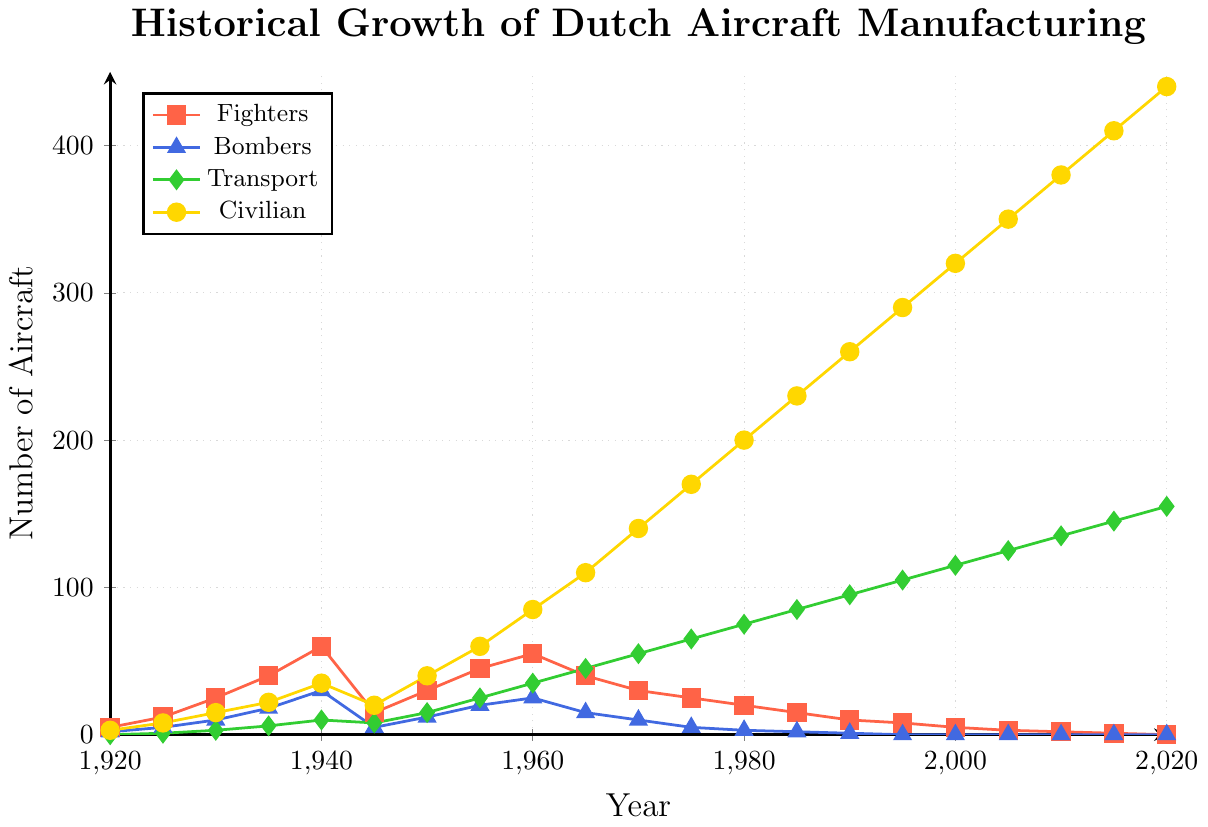What year marked the highest production of fighters, and how many were produced? The peak value on the red line representing fighters occurs in 1940, with the highest number of fighters produced. Analyzing this point shows there were 60 fighters produced.
Answer: 1940, 60 What is the overall trend in the production of civilian aircraft from 1920 to 2020? The yellow line representing civilian aircraft consistently increases over the entire period from 1920 to 2020, indicating a steady rise in the production of civilian aircraft.
Answer: Steady increase In which period did transport aircraft production increase the most rapidly? The green line representing transport aircraft shows the steepest rise between 1940 and 1960, indicating the most rapid increase during this period.
Answer: 1940 to 1960 Compare the production of bombers in 1940 and 1950. How much did it change, and in which direction? From the graph, in 1940, the number of bombers produced was 30, while in 1950, it was 12. This shows a decrease of 18 bombers from 1940 to 1950.
Answer: Decreased by 18 What is the combined total of civilian and transport aircraft produced in 2020, and how does it compare to the total in 1980? In 2020, the production numbers are 440 for civilian aircraft and 155 for transport aircraft, resulting in a combined total of 595. In 1980, the combined total is 200 (civilian) + 75 (transport) = 275. Comparing these, 595 - 275 = 320, showing an increase of 320 aircraft.
Answer: Increase of 320 Which aircraft type saw a complete ending in production before 2020? The blue line representing bombers reaches zero and stays constant from 1995 onwards, indicating that their production ended before 2020.
Answer: Bombers Describe the visual difference between the production trends of fighters and civilian aircraft from 1950 onwards. The red line for fighters shows a general decline from 1950 onwards, while the yellow line for civilian aircraft shows a continual upward trend, becoming the most prominent visual element by 2020.
Answer: Fighters decline, civilian aircraft rise What is the difference in total aircraft production (across all types) between the years 1940 and 1945? Summing the values for each aircraft type in 1940 gives 60 (fighters) + 30 (bombers) + 10 (transport) + 35 (civilian) = 135. For 1945, the values are 15 (fighters) + 5 (bombers) + 8 (transport) + 20 (civilian) = 48. The difference is 135 - 48 = 87.
Answer: 87 How does the production of fighters in 1970 compare to that of transport aircraft in the same year? In 1970, the red line shows the production of fighters at 30, while the green line for transport aircraft shows a production of 55, indicating that transport aircraft production exceeded fighter production by 25 units.
Answer: 25 more transport aircraft What is the median value of civilian aircraft produced from 1920 to 2020? Listing the production values for civilian aircraft: 3, 8, 15, 22, 35, 20, 40, 60, 85, 110, 140, 170, 200, 230, 260, 290, 320, 350, 380, 410, 440. The median value, being the middle of this ordered list, is 140 (the 11th value).
Answer: 140 